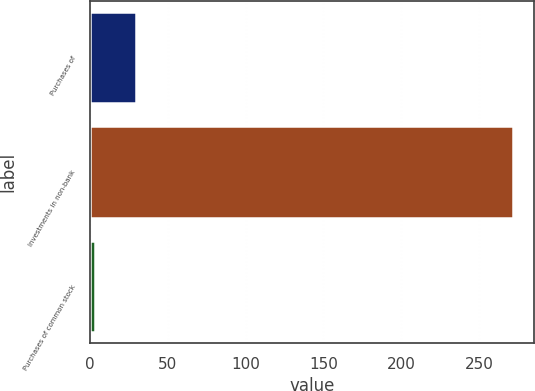Convert chart to OTSL. <chart><loc_0><loc_0><loc_500><loc_500><bar_chart><fcel>Purchases of<fcel>Investments in non-bank<fcel>Purchases of common stock<nl><fcel>29.9<fcel>272<fcel>3<nl></chart> 